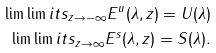<formula> <loc_0><loc_0><loc_500><loc_500>\lim \lim i t s _ { z \rightarrow - \infty } E ^ { u } ( \lambda , z ) = U ( \lambda ) \\ \lim \lim i t s _ { z \rightarrow \infty } E ^ { s } ( \lambda , z ) = S ( \lambda ) .</formula> 